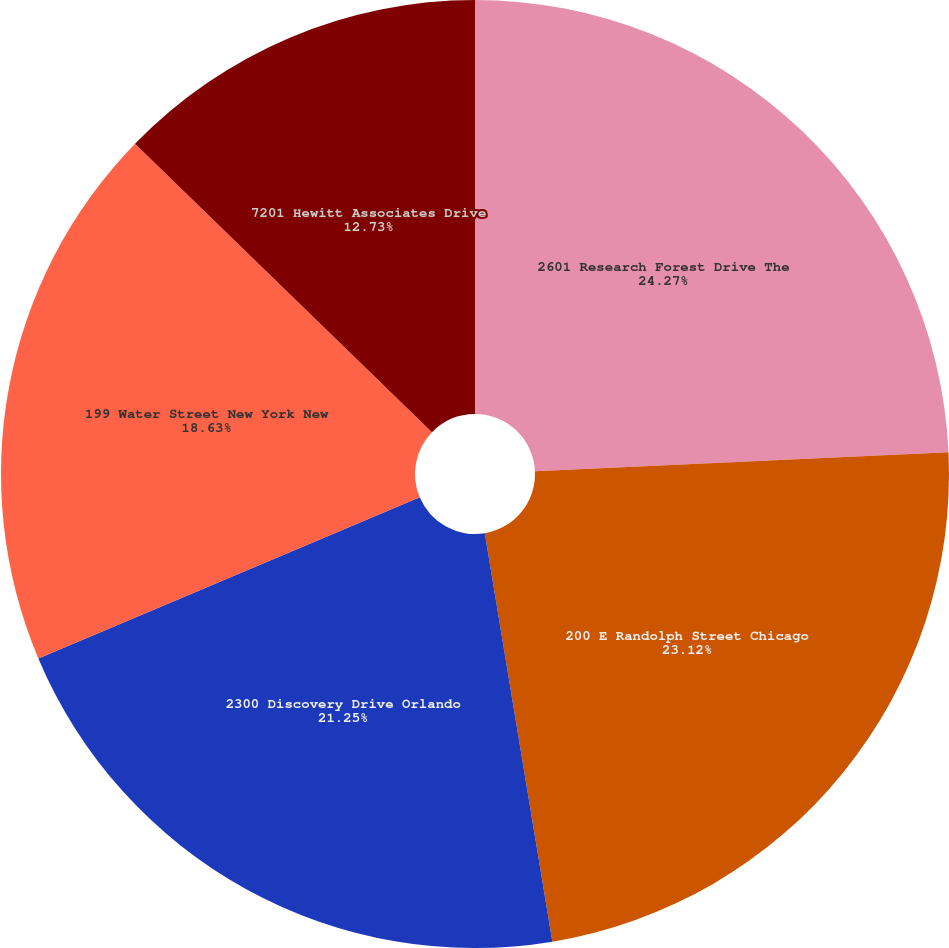Convert chart. <chart><loc_0><loc_0><loc_500><loc_500><pie_chart><fcel>2601 Research Forest Drive The<fcel>200 E Randolph Street Chicago<fcel>2300 Discovery Drive Orlando<fcel>199 Water Street New York New<fcel>7201 Hewitt Associates Drive<nl><fcel>24.27%<fcel>23.12%<fcel>21.25%<fcel>18.63%<fcel>12.73%<nl></chart> 